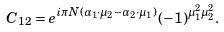<formula> <loc_0><loc_0><loc_500><loc_500>C _ { 1 2 } = e ^ { i \pi N ( \alpha _ { 1 } \cdot \mu _ { 2 } - \alpha _ { 2 } \cdot \mu _ { 1 } ) } ( - 1 ) ^ { \mu _ { 1 } ^ { 2 } \mu _ { 2 } ^ { 2 } } .</formula> 